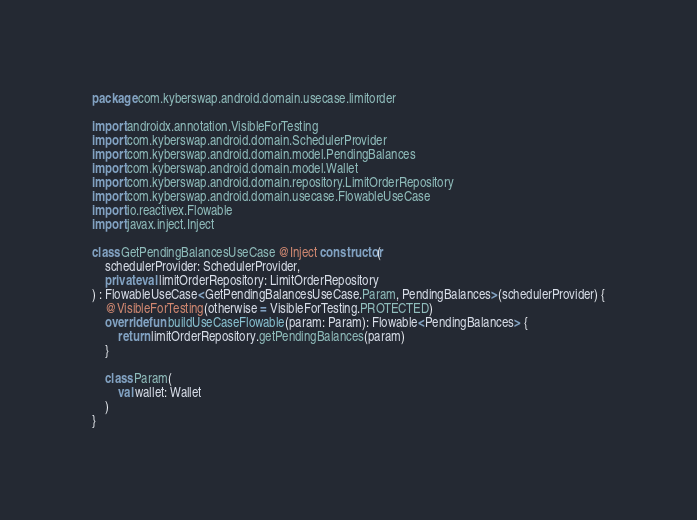Convert code to text. <code><loc_0><loc_0><loc_500><loc_500><_Kotlin_>package com.kyberswap.android.domain.usecase.limitorder

import androidx.annotation.VisibleForTesting
import com.kyberswap.android.domain.SchedulerProvider
import com.kyberswap.android.domain.model.PendingBalances
import com.kyberswap.android.domain.model.Wallet
import com.kyberswap.android.domain.repository.LimitOrderRepository
import com.kyberswap.android.domain.usecase.FlowableUseCase
import io.reactivex.Flowable
import javax.inject.Inject

class GetPendingBalancesUseCase @Inject constructor(
    schedulerProvider: SchedulerProvider,
    private val limitOrderRepository: LimitOrderRepository
) : FlowableUseCase<GetPendingBalancesUseCase.Param, PendingBalances>(schedulerProvider) {
    @VisibleForTesting(otherwise = VisibleForTesting.PROTECTED)
    override fun buildUseCaseFlowable(param: Param): Flowable<PendingBalances> {
        return limitOrderRepository.getPendingBalances(param)
    }

    class Param(
        val wallet: Wallet
    )
}
</code> 